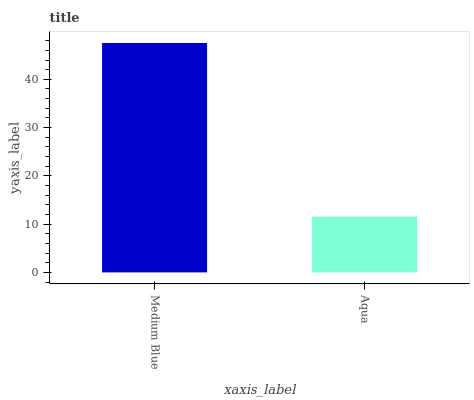Is Aqua the minimum?
Answer yes or no. Yes. Is Medium Blue the maximum?
Answer yes or no. Yes. Is Aqua the maximum?
Answer yes or no. No. Is Medium Blue greater than Aqua?
Answer yes or no. Yes. Is Aqua less than Medium Blue?
Answer yes or no. Yes. Is Aqua greater than Medium Blue?
Answer yes or no. No. Is Medium Blue less than Aqua?
Answer yes or no. No. Is Medium Blue the high median?
Answer yes or no. Yes. Is Aqua the low median?
Answer yes or no. Yes. Is Aqua the high median?
Answer yes or no. No. Is Medium Blue the low median?
Answer yes or no. No. 